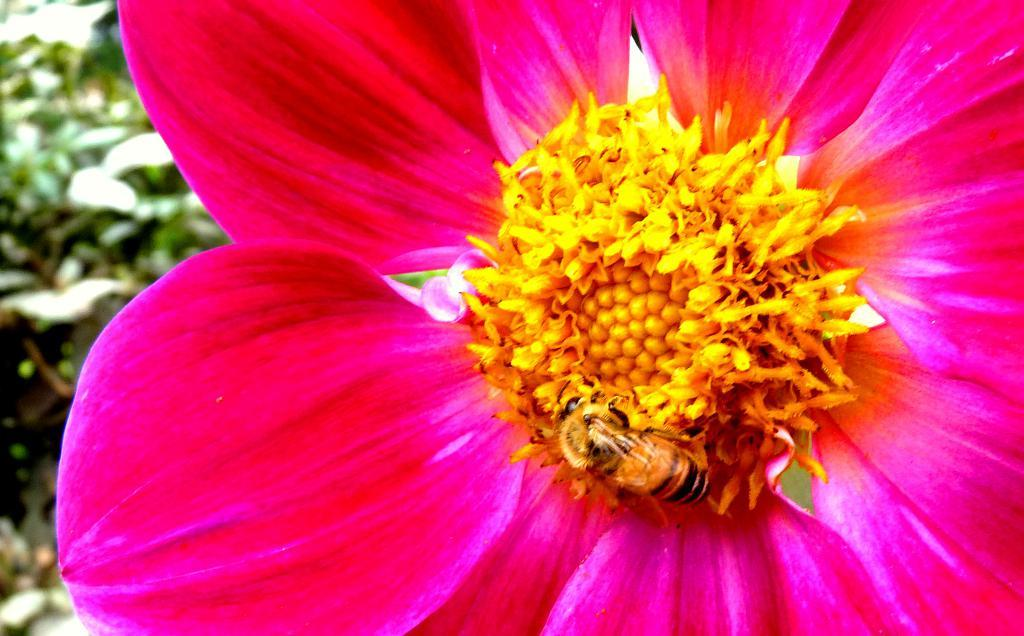What type of flower is in the image? There is a pink and yellow flower in the image. Is there any wildlife interacting with the flower? Yes, there is a honey bee on the flower. What color is the background of the image? The background is green and blurred. How many legs can be seen on the creature in the image? There is no creature present in the image, only a flower and a honey bee. The honey bee has six legs, but they are not visible in the image. 